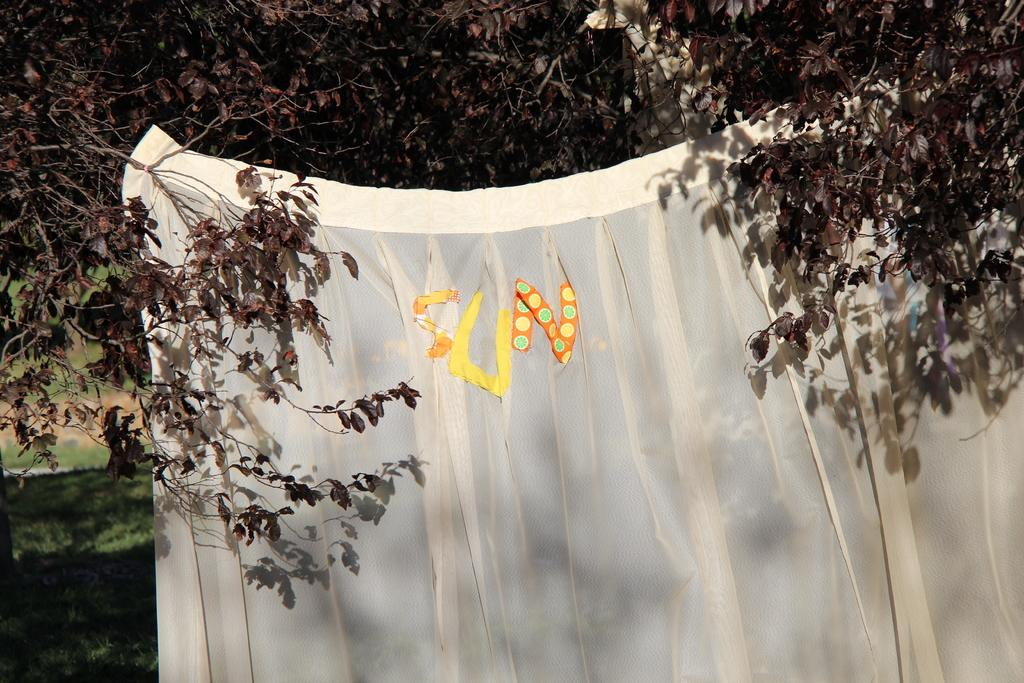What is the main object in the image? There is a white sheet or cloth in the image. What is written or pasted on the sheet or cloth? "SUN" stickers or alphabets are pasted on the sheet or cloth. What type of natural environment is visible in the image? There is grass in the left bottom of the image, and trees are in the background. Where can we find the store selling these stickers in the image? There is no store present in the image; it only shows a white sheet or cloth with "SUN" stickers or alphabets. What type of badge is being worn by the person in the image? There is no person or badge visible in the image. 